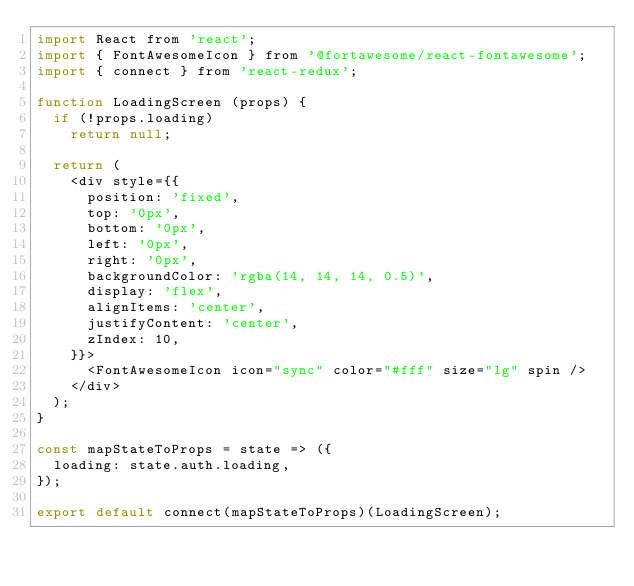<code> <loc_0><loc_0><loc_500><loc_500><_JavaScript_>import React from 'react';
import { FontAwesomeIcon } from '@fortawesome/react-fontawesome';
import { connect } from 'react-redux';

function LoadingScreen (props) {
  if (!props.loading)
    return null;

  return (
    <div style={{
      position: 'fixed',
      top: '0px',
      bottom: '0px',
      left: '0px',
      right: '0px',
      backgroundColor: 'rgba(14, 14, 14, 0.5)',
      display: 'flex',
      alignItems: 'center',
      justifyContent: 'center',
      zIndex: 10,
    }}>
      <FontAwesomeIcon icon="sync" color="#fff" size="lg" spin />
    </div>
  );
}

const mapStateToProps = state => ({
  loading: state.auth.loading,
});

export default connect(mapStateToProps)(LoadingScreen);</code> 